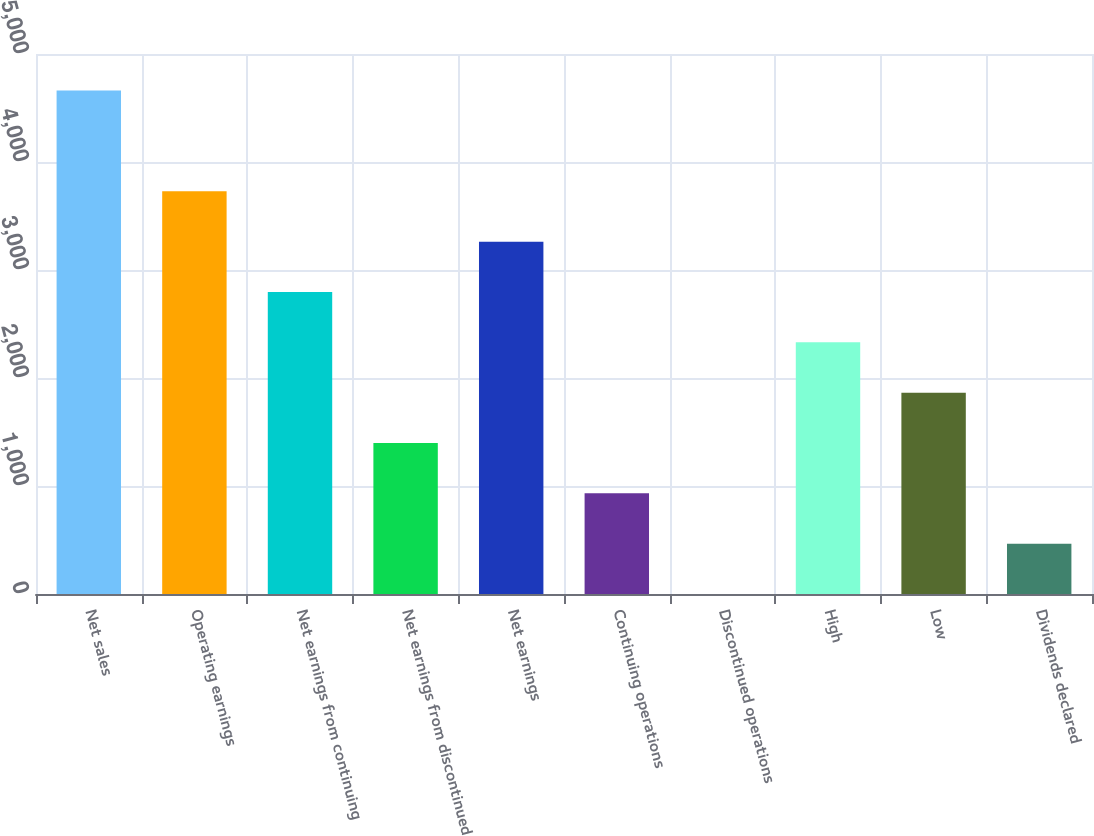<chart> <loc_0><loc_0><loc_500><loc_500><bar_chart><fcel>Net sales<fcel>Operating earnings<fcel>Net earnings from continuing<fcel>Net earnings from discontinued<fcel>Net earnings<fcel>Continuing operations<fcel>Discontinued operations<fcel>High<fcel>Low<fcel>Dividends declared<nl><fcel>4661<fcel>3728.83<fcel>2796.63<fcel>1398.33<fcel>3262.73<fcel>932.23<fcel>0.03<fcel>2330.53<fcel>1864.43<fcel>466.13<nl></chart> 